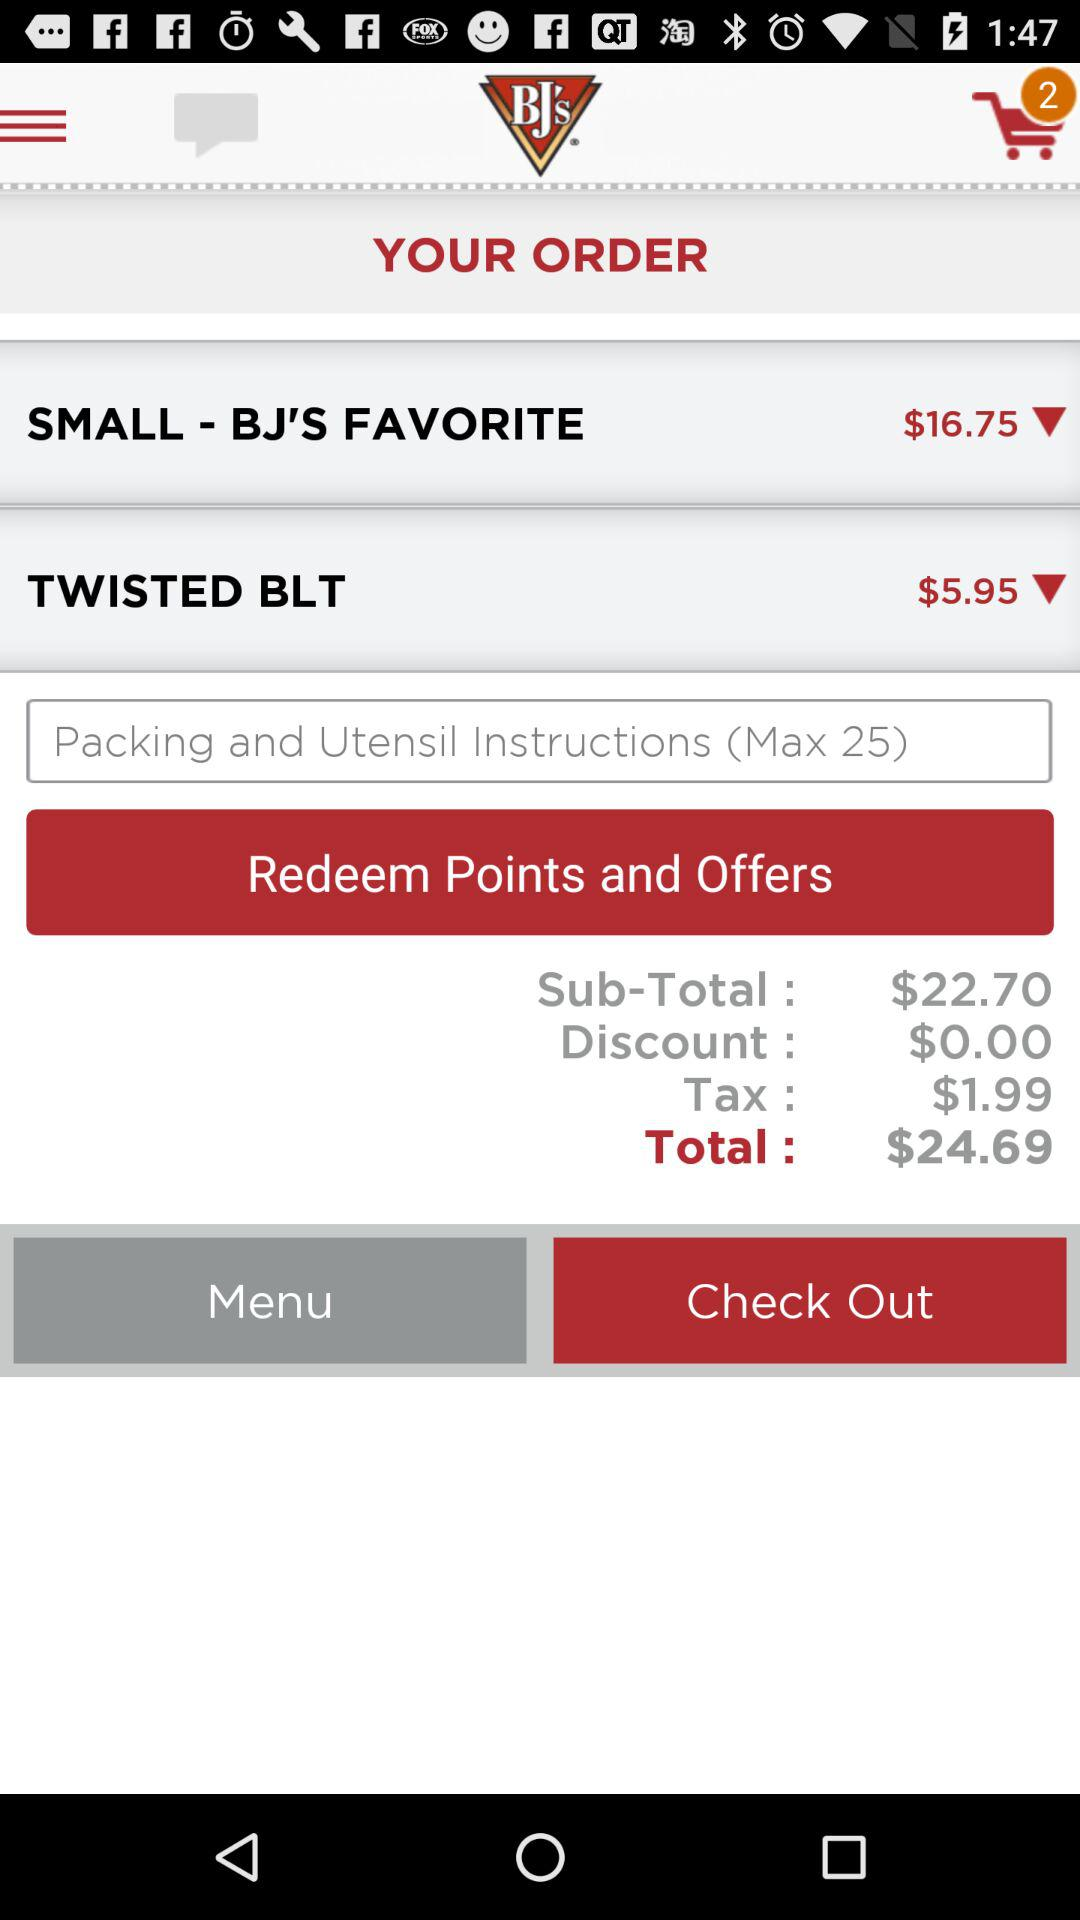How many items are in the cart? There are 2 items in the cart. 